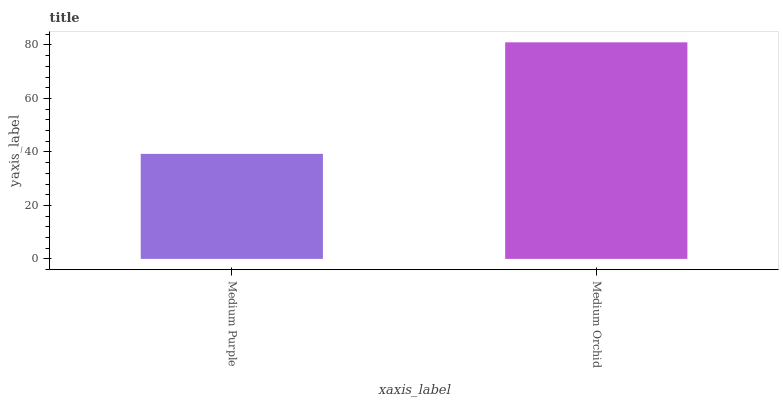Is Medium Purple the minimum?
Answer yes or no. Yes. Is Medium Orchid the maximum?
Answer yes or no. Yes. Is Medium Orchid the minimum?
Answer yes or no. No. Is Medium Orchid greater than Medium Purple?
Answer yes or no. Yes. Is Medium Purple less than Medium Orchid?
Answer yes or no. Yes. Is Medium Purple greater than Medium Orchid?
Answer yes or no. No. Is Medium Orchid less than Medium Purple?
Answer yes or no. No. Is Medium Orchid the high median?
Answer yes or no. Yes. Is Medium Purple the low median?
Answer yes or no. Yes. Is Medium Purple the high median?
Answer yes or no. No. Is Medium Orchid the low median?
Answer yes or no. No. 